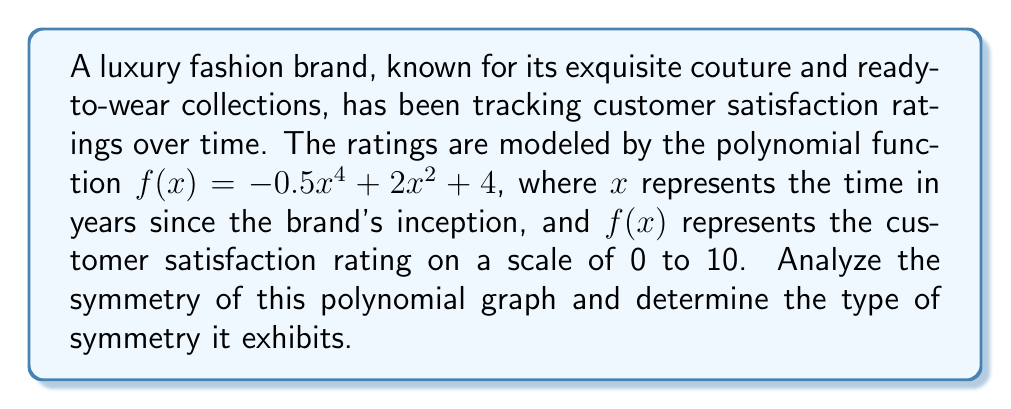Solve this math problem. To analyze the symmetry of the polynomial graph, we need to follow these steps:

1. Identify the degree of the polynomial:
   The polynomial is $f(x) = -0.5x^4 + 2x^2 + 4$, which is a 4th-degree (quartic) polynomial.

2. Examine the terms of the polynomial:
   - The polynomial contains only even powers of x: $x^4$ and $x^2$.
   - There are no odd power terms (e.g., $x^3$ or $x$).
   - The constant term (4) is present.

3. Consider the general form of even-degree polynomials:
   Even-degree polynomials with only even power terms and a constant term are symmetric about the y-axis.

4. Verify the symmetry:
   To confirm y-axis symmetry, we can check if $f(x) = f(-x)$ for all x:
   $f(x) = -0.5x^4 + 2x^2 + 4$
   $f(-x) = -0.5(-x)^4 + 2(-x)^2 + 4$
          $= -0.5x^4 + 2x^2 + 4$
   
   Since $f(x) = f(-x)$, the function is indeed symmetric about the y-axis.

5. Visualize the graph:
   The graph will be a W-shaped curve that is perfectly mirrored on either side of the y-axis.

Therefore, the polynomial graph depicting customer satisfaction ratings over time exhibits symmetry about the y-axis.
Answer: The polynomial graph $f(x) = -0.5x^4 + 2x^2 + 4$ exhibits y-axis symmetry. 